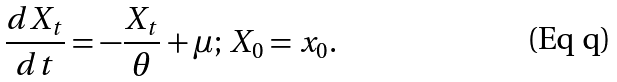Convert formula to latex. <formula><loc_0><loc_0><loc_500><loc_500>\frac { d X _ { t } } { d t } = - \frac { X _ { t } } { \theta } + \mu ; \, X _ { 0 } = x _ { 0 } .</formula> 